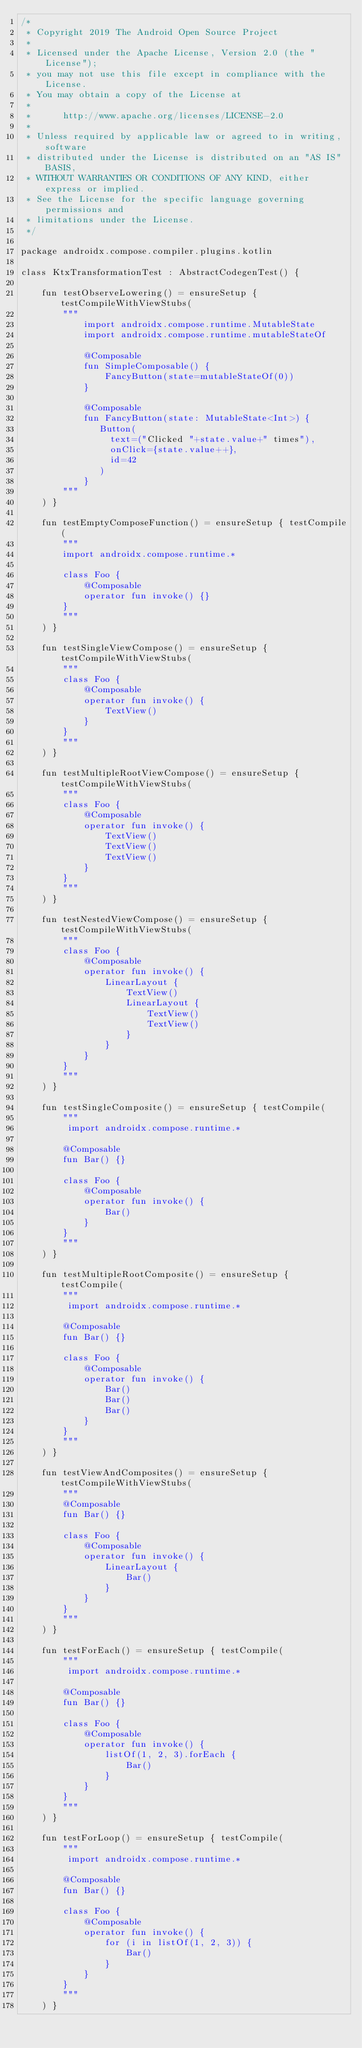<code> <loc_0><loc_0><loc_500><loc_500><_Kotlin_>/*
 * Copyright 2019 The Android Open Source Project
 *
 * Licensed under the Apache License, Version 2.0 (the "License");
 * you may not use this file except in compliance with the License.
 * You may obtain a copy of the License at
 *
 *      http://www.apache.org/licenses/LICENSE-2.0
 *
 * Unless required by applicable law or agreed to in writing, software
 * distributed under the License is distributed on an "AS IS" BASIS,
 * WITHOUT WARRANTIES OR CONDITIONS OF ANY KIND, either express or implied.
 * See the License for the specific language governing permissions and
 * limitations under the License.
 */

package androidx.compose.compiler.plugins.kotlin

class KtxTransformationTest : AbstractCodegenTest() {

    fun testObserveLowering() = ensureSetup { testCompileWithViewStubs(
        """
            import androidx.compose.runtime.MutableState
            import androidx.compose.runtime.mutableStateOf

            @Composable
            fun SimpleComposable() {
                FancyButton(state=mutableStateOf(0))
            }

            @Composable
            fun FancyButton(state: MutableState<Int>) {
               Button(
                 text=("Clicked "+state.value+" times"),
                 onClick={state.value++},
                 id=42
               )
            }
        """
    ) }

    fun testEmptyComposeFunction() = ensureSetup { testCompile(
        """
        import androidx.compose.runtime.*

        class Foo {
            @Composable
            operator fun invoke() {}
        }
        """
    ) }

    fun testSingleViewCompose() = ensureSetup { testCompileWithViewStubs(
        """
        class Foo {
            @Composable
            operator fun invoke() {
                TextView()
            }
        }
        """
    ) }

    fun testMultipleRootViewCompose() = ensureSetup { testCompileWithViewStubs(
        """
        class Foo {
            @Composable
            operator fun invoke() {
                TextView()
                TextView()
                TextView()
            }
        }
        """
    ) }

    fun testNestedViewCompose() = ensureSetup { testCompileWithViewStubs(
        """
        class Foo {
            @Composable
            operator fun invoke() {
                LinearLayout {
                    TextView()
                    LinearLayout {
                        TextView()
                        TextView()
                    }
                }
            }
        }
        """
    ) }

    fun testSingleComposite() = ensureSetup { testCompile(
        """
         import androidx.compose.runtime.*

        @Composable
        fun Bar() {}

        class Foo {
            @Composable
            operator fun invoke() {
                Bar()
            }
        }
        """
    ) }

    fun testMultipleRootComposite() = ensureSetup { testCompile(
        """
         import androidx.compose.runtime.*

        @Composable
        fun Bar() {}

        class Foo {
            @Composable
            operator fun invoke() {
                Bar()
                Bar()
                Bar()
            }
        }
        """
    ) }

    fun testViewAndComposites() = ensureSetup { testCompileWithViewStubs(
        """
        @Composable
        fun Bar() {}

        class Foo {
            @Composable
            operator fun invoke() {
                LinearLayout {
                    Bar()
                }
            }
        }
        """
    ) }

    fun testForEach() = ensureSetup { testCompile(
        """
         import androidx.compose.runtime.*

        @Composable
        fun Bar() {}

        class Foo {
            @Composable
            operator fun invoke() {
                listOf(1, 2, 3).forEach {
                    Bar()
                }
            }
        }
        """
    ) }

    fun testForLoop() = ensureSetup { testCompile(
        """
         import androidx.compose.runtime.*

        @Composable
        fun Bar() {}

        class Foo {
            @Composable
            operator fun invoke() {
                for (i in listOf(1, 2, 3)) {
                    Bar()
                }
            }
        }
        """
    ) }
</code> 